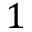<formula> <loc_0><loc_0><loc_500><loc_500>1</formula> 